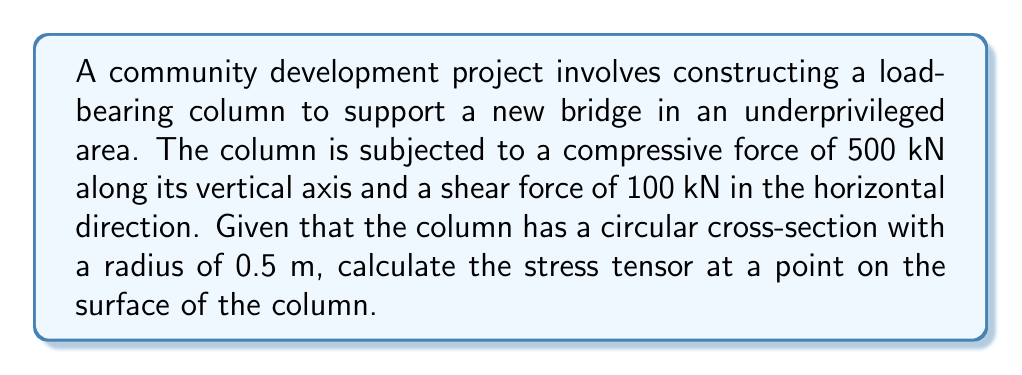Can you solve this math problem? To calculate the stress tensor for the load-bearing column, we'll follow these steps:

1. Determine the cross-sectional area of the column:
   $$A = \pi r^2 = \pi (0.5\text{ m})^2 = 0.7854\text{ m}^2$$

2. Calculate the normal stress due to the compressive force:
   $$\sigma_{zz} = \frac{F_z}{A} = \frac{500\text{ kN}}{0.7854\text{ m}^2} = 636.62\text{ kPa}$$

3. Calculate the shear stress due to the horizontal force:
   $$\tau_{xz} = \tau_{zx} = \frac{F_x}{A} = \frac{100\text{ kN}}{0.7854\text{ m}^2} = 127.32\text{ kPa}$$

4. Construct the stress tensor:
   The stress tensor in 3D Cartesian coordinates is given by:
   $$\sigma = \begin{bmatrix}
   \sigma_{xx} & \tau_{xy} & \tau_{xz} \\
   \tau_{yx} & \sigma_{yy} & \tau_{yz} \\
   \tau_{zx} & \tau_{zy} & \sigma_{zz}
   \end{bmatrix}$$

   In this case, we have:
   $$\sigma = \begin{bmatrix}
   0 & 0 & 127.32 \\
   0 & 0 & 0 \\
   127.32 & 0 & -636.62
   \end{bmatrix}\text{ kPa}$$

   Note: The negative sign for $\sigma_{zz}$ indicates compression.
Answer: $$\sigma = \begin{bmatrix}
0 & 0 & 127.32 \\
0 & 0 & 0 \\
127.32 & 0 & -636.62
\end{bmatrix}\text{ kPa}$$ 